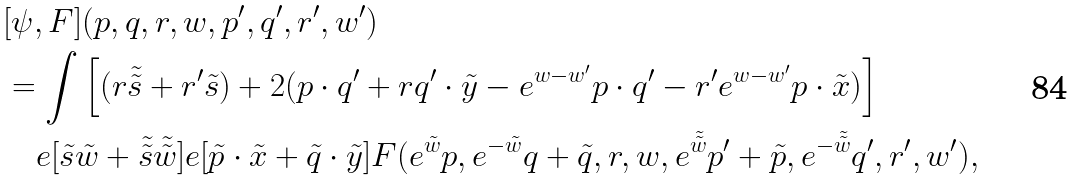Convert formula to latex. <formula><loc_0><loc_0><loc_500><loc_500>& [ \psi , F ] ( p , q , r , w , p ^ { \prime } , q ^ { \prime } , r ^ { \prime } , w ^ { \prime } ) \\ & = \int \left [ ( r \tilde { \tilde { s } } + r ^ { \prime } \tilde { s } ) + 2 ( p \cdot q ^ { \prime } + r q ^ { \prime } \cdot \tilde { y } - e ^ { w - w ^ { \prime } } p \cdot q ^ { \prime } - r ^ { \prime } e ^ { w - w ^ { \prime } } p \cdot \tilde { x } ) \right ] \\ & \quad e [ \tilde { s } \tilde { w } + \tilde { \tilde { s } } \tilde { \tilde { w } } ] e [ \tilde { p } \cdot \tilde { x } + \tilde { q } \cdot \tilde { y } ] F ( e ^ { \tilde { w } } p , e ^ { - \tilde { w } } q + \tilde { q } , r , w , e ^ { \tilde { \tilde { w } } } p ^ { \prime } + \tilde { p } , e ^ { - \tilde { \tilde { w } } } q ^ { \prime } , r ^ { \prime } , w ^ { \prime } ) ,</formula> 